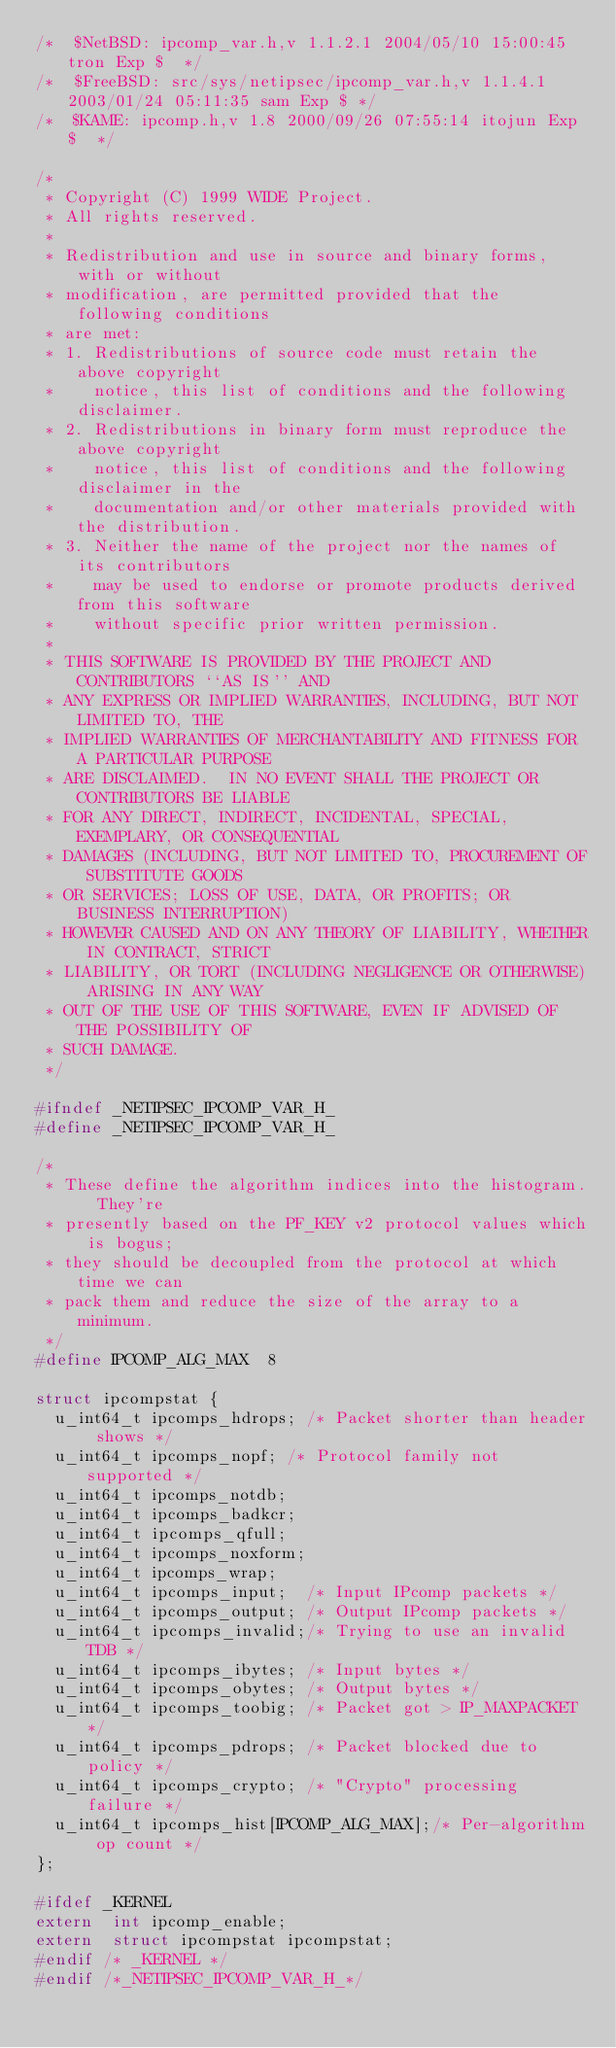Convert code to text. <code><loc_0><loc_0><loc_500><loc_500><_C_>/*	$NetBSD: ipcomp_var.h,v 1.1.2.1 2004/05/10 15:00:45 tron Exp $	*/
/*	$FreeBSD: src/sys/netipsec/ipcomp_var.h,v 1.1.4.1 2003/01/24 05:11:35 sam Exp $	*/
/*	$KAME: ipcomp.h,v 1.8 2000/09/26 07:55:14 itojun Exp $	*/

/*
 * Copyright (C) 1999 WIDE Project.
 * All rights reserved.
 *
 * Redistribution and use in source and binary forms, with or without
 * modification, are permitted provided that the following conditions
 * are met:
 * 1. Redistributions of source code must retain the above copyright
 *    notice, this list of conditions and the following disclaimer.
 * 2. Redistributions in binary form must reproduce the above copyright
 *    notice, this list of conditions and the following disclaimer in the
 *    documentation and/or other materials provided with the distribution.
 * 3. Neither the name of the project nor the names of its contributors
 *    may be used to endorse or promote products derived from this software
 *    without specific prior written permission.
 *
 * THIS SOFTWARE IS PROVIDED BY THE PROJECT AND CONTRIBUTORS ``AS IS'' AND
 * ANY EXPRESS OR IMPLIED WARRANTIES, INCLUDING, BUT NOT LIMITED TO, THE
 * IMPLIED WARRANTIES OF MERCHANTABILITY AND FITNESS FOR A PARTICULAR PURPOSE
 * ARE DISCLAIMED.  IN NO EVENT SHALL THE PROJECT OR CONTRIBUTORS BE LIABLE
 * FOR ANY DIRECT, INDIRECT, INCIDENTAL, SPECIAL, EXEMPLARY, OR CONSEQUENTIAL
 * DAMAGES (INCLUDING, BUT NOT LIMITED TO, PROCUREMENT OF SUBSTITUTE GOODS
 * OR SERVICES; LOSS OF USE, DATA, OR PROFITS; OR BUSINESS INTERRUPTION)
 * HOWEVER CAUSED AND ON ANY THEORY OF LIABILITY, WHETHER IN CONTRACT, STRICT
 * LIABILITY, OR TORT (INCLUDING NEGLIGENCE OR OTHERWISE) ARISING IN ANY WAY
 * OUT OF THE USE OF THIS SOFTWARE, EVEN IF ADVISED OF THE POSSIBILITY OF
 * SUCH DAMAGE.
 */

#ifndef _NETIPSEC_IPCOMP_VAR_H_
#define _NETIPSEC_IPCOMP_VAR_H_

/*
 * These define the algorithm indices into the histogram.  They're
 * presently based on the PF_KEY v2 protocol values which is bogus;
 * they should be decoupled from the protocol at which time we can
 * pack them and reduce the size of the array to a minimum.
 */
#define	IPCOMP_ALG_MAX	8

struct ipcompstat {
	u_int64_t	ipcomps_hdrops;	/* Packet shorter than header shows */
	u_int64_t	ipcomps_nopf;	/* Protocol family not supported */
	u_int64_t	ipcomps_notdb;
	u_int64_t	ipcomps_badkcr;
	u_int64_t	ipcomps_qfull;
	u_int64_t	ipcomps_noxform;
	u_int64_t	ipcomps_wrap;
	u_int64_t	ipcomps_input;	/* Input IPcomp packets */
	u_int64_t	ipcomps_output;	/* Output IPcomp packets */
	u_int64_t	ipcomps_invalid;/* Trying to use an invalid TDB */
	u_int64_t	ipcomps_ibytes;	/* Input bytes */
	u_int64_t	ipcomps_obytes;	/* Output bytes */
	u_int64_t	ipcomps_toobig;	/* Packet got > IP_MAXPACKET */
	u_int64_t	ipcomps_pdrops;	/* Packet blocked due to policy */
	u_int64_t	ipcomps_crypto;	/* "Crypto" processing failure */
	u_int64_t	ipcomps_hist[IPCOMP_ALG_MAX];/* Per-algorithm op count */
};

#ifdef _KERNEL
extern	int ipcomp_enable;
extern	struct ipcompstat ipcompstat;
#endif /* _KERNEL */
#endif /*_NETIPSEC_IPCOMP_VAR_H_*/
</code> 